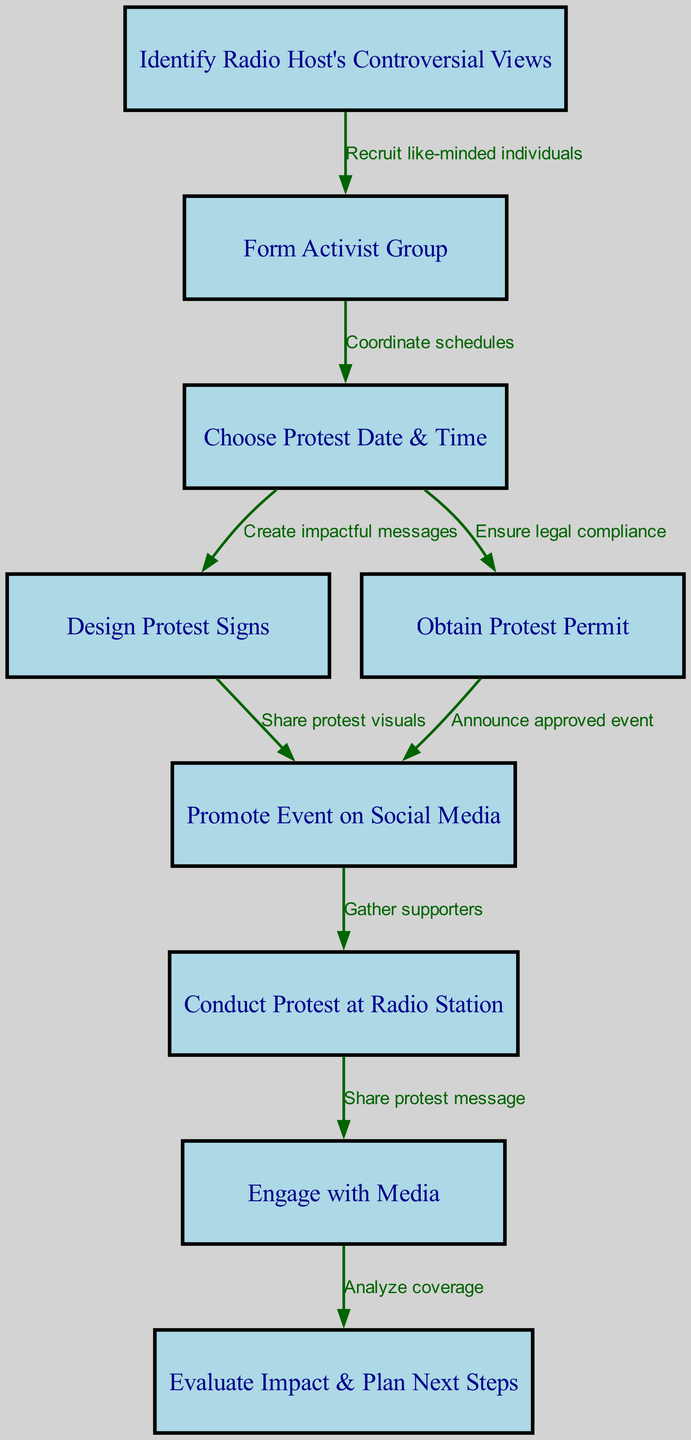What is the first step in organizing a protest according to the diagram? The diagram shows the first node labeled "Identify Radio Host's Controversial Views," which is the initial step in the process.
Answer: Identify Radio Host's Controversial Views How many nodes are there in the diagram? By counting each label in the diagram's nodes section, we find there are a total of nine nodes representing different steps in the protest organization process.
Answer: 9 What is the label of the node that connects "Obtain Protest Permit" and "Promote Event on Social Media"? The edge between these two nodes is labeled "Announce approved event," indicating the relationship between obtaining a permit and promoting the event.
Answer: Announce approved event What action follows after conducting the protest at the radio station? The diagram indicates that "Engage with Media" is the next step after the protest, making this the action to occur following the event.
Answer: Engage with Media What is the relationship between “Design Protest Signs” and “Promote Event on Social Media”? The edge connecting these two nodes is labeled "Share protest visuals," indicating that after designing signs, the visuals will be shared for promotion.
Answer: Share protest visuals What must be ensured before promoting the event on social media? The edge "Ensure legal compliance" implies that obtaining a protest permit is essential before promoting the event publicly.
Answer: Ensure legal compliance What is the last step in the process outlined in the diagram? The final node is "Evaluate Impact & Plan Next Steps," indicating that after engaging with the media, the process concludes with an assessment of the protest.
Answer: Evaluate Impact & Plan Next Steps 